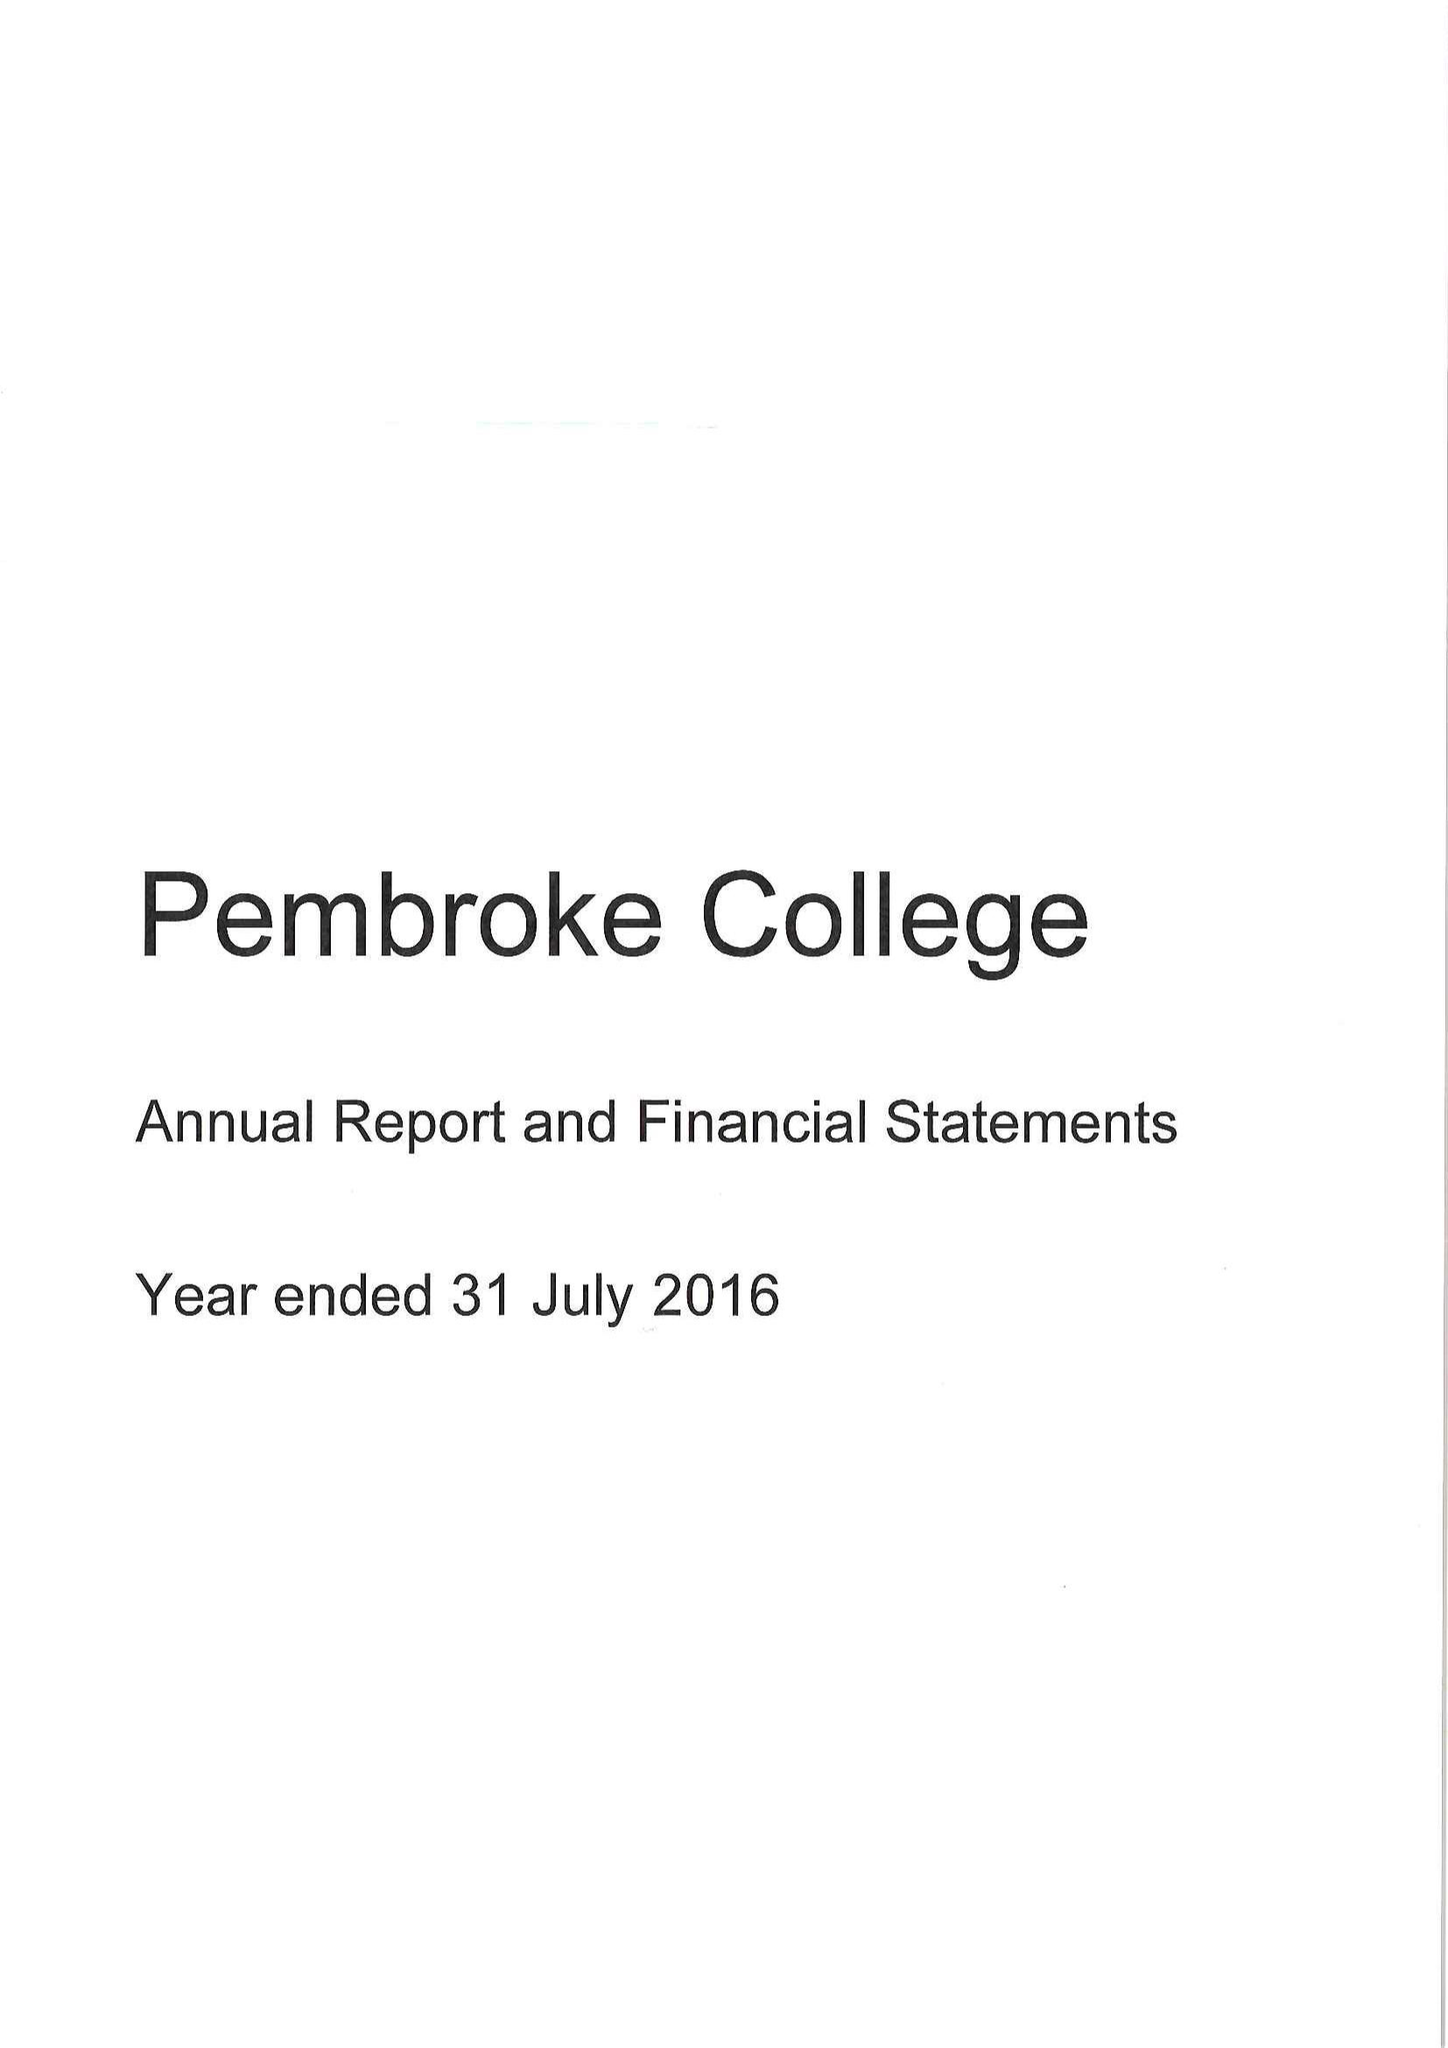What is the value for the income_annually_in_british_pounds?
Answer the question using a single word or phrase. 10961000.00 